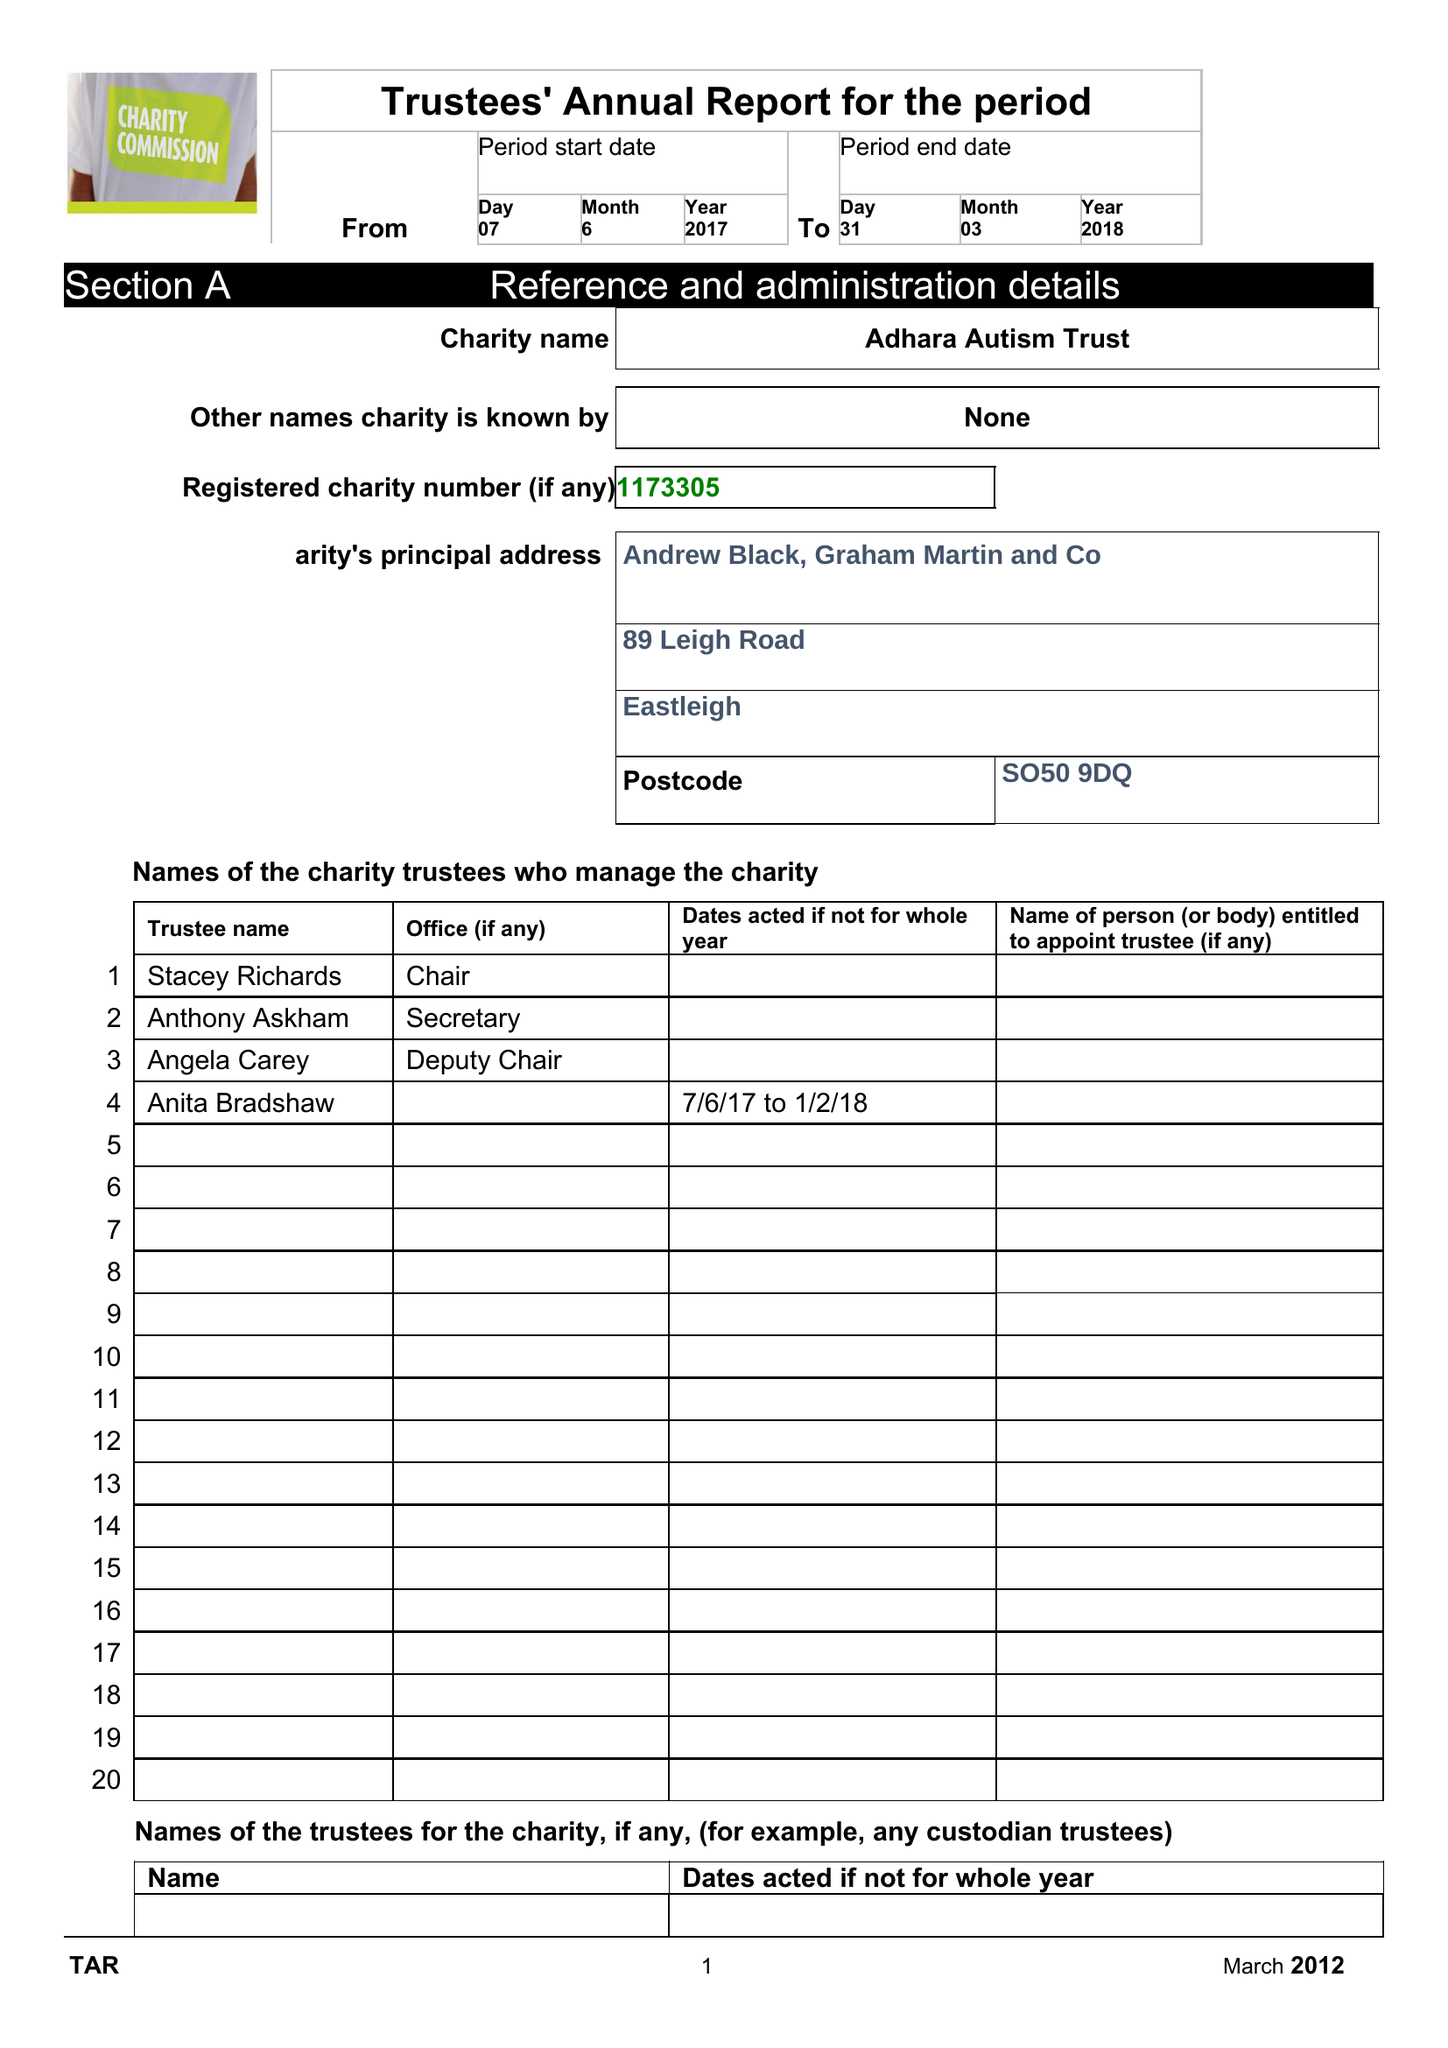What is the value for the spending_annually_in_british_pounds?
Answer the question using a single word or phrase. None 